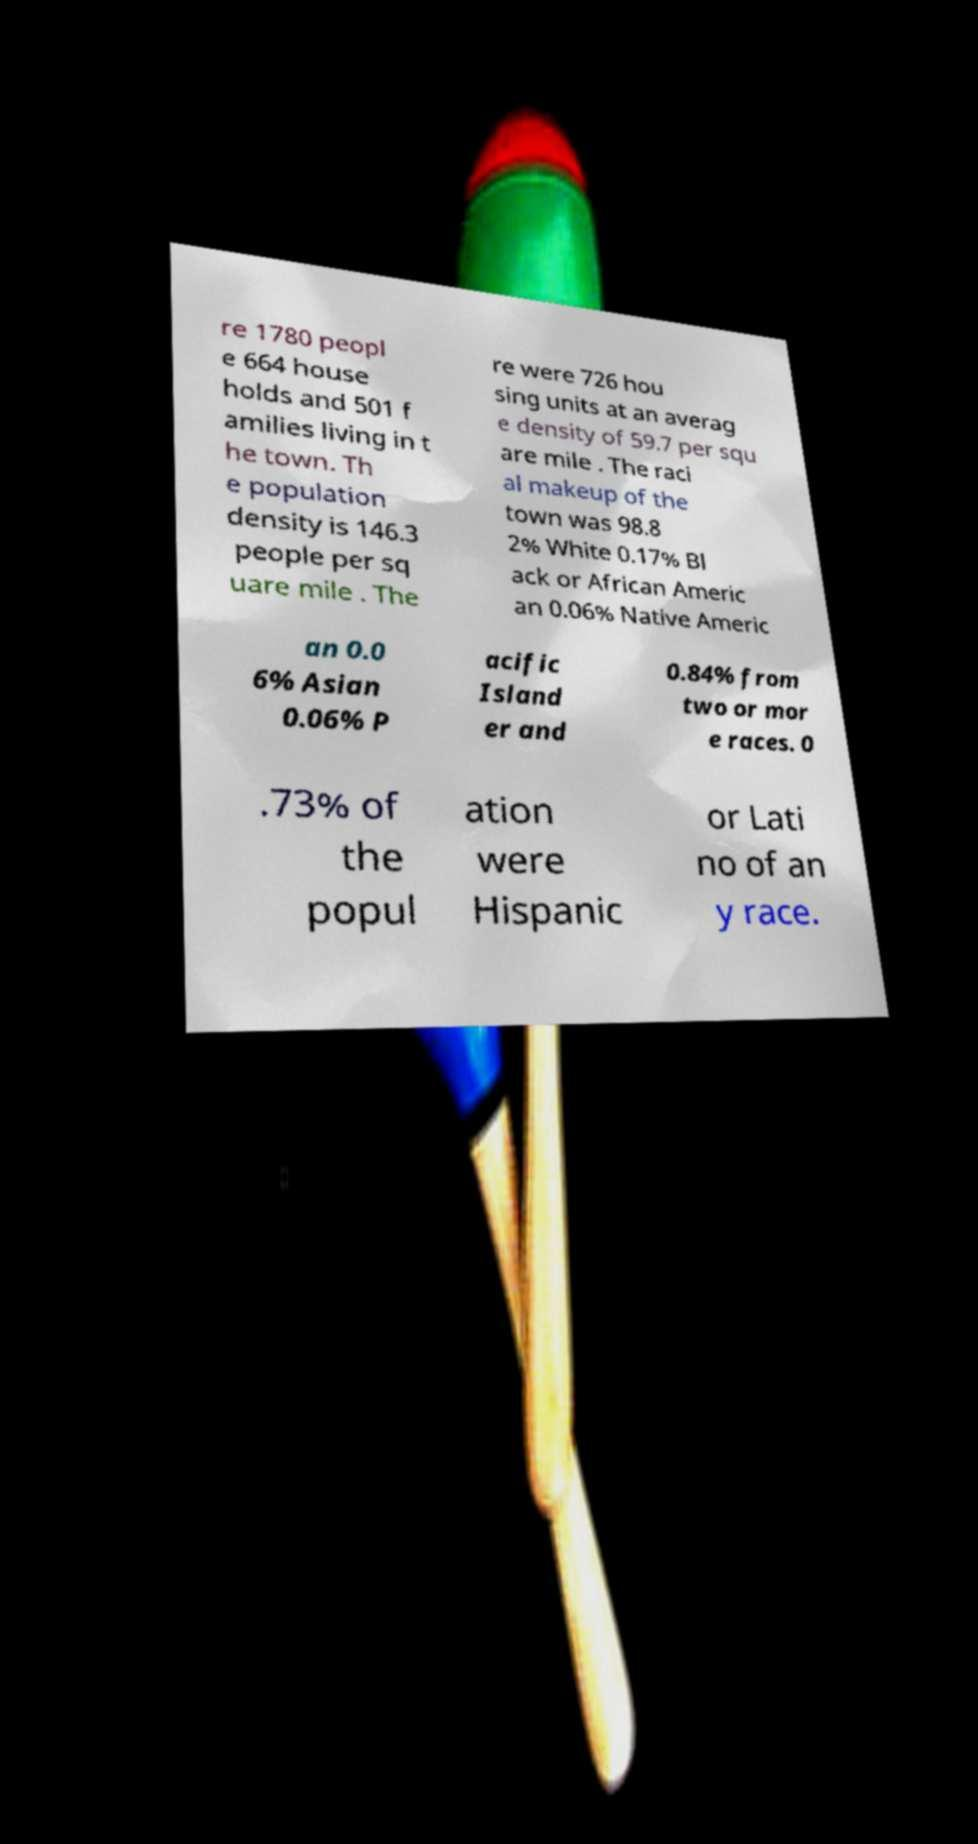Can you accurately transcribe the text from the provided image for me? re 1780 peopl e 664 house holds and 501 f amilies living in t he town. Th e population density is 146.3 people per sq uare mile . The re were 726 hou sing units at an averag e density of 59.7 per squ are mile . The raci al makeup of the town was 98.8 2% White 0.17% Bl ack or African Americ an 0.06% Native Americ an 0.0 6% Asian 0.06% P acific Island er and 0.84% from two or mor e races. 0 .73% of the popul ation were Hispanic or Lati no of an y race. 